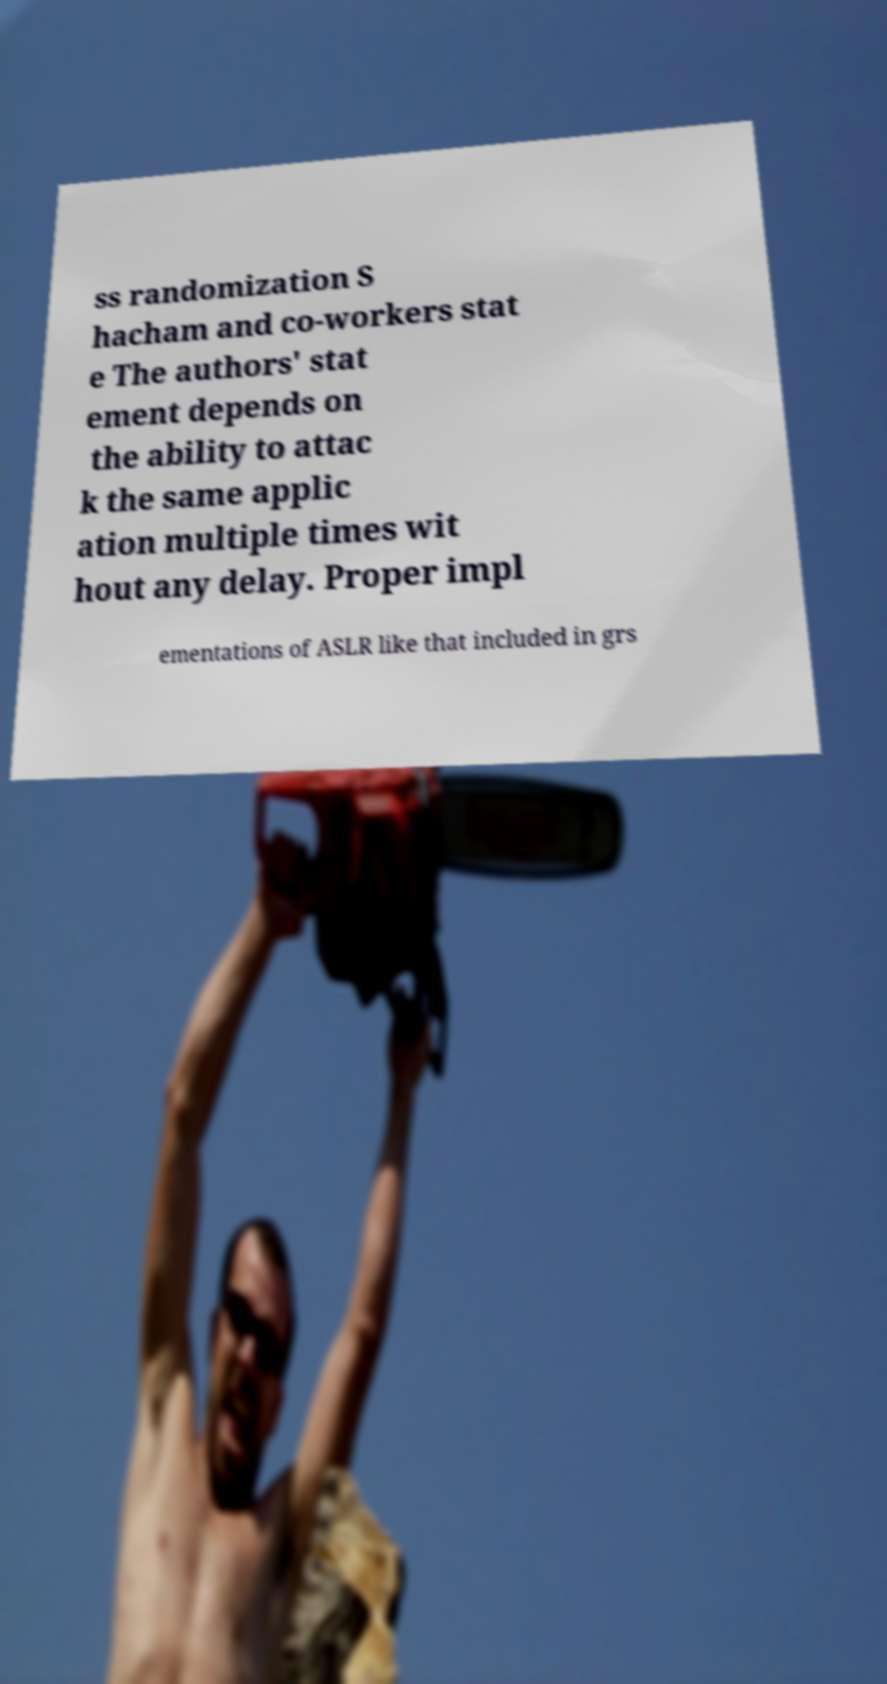What messages or text are displayed in this image? I need them in a readable, typed format. ss randomization S hacham and co-workers stat e The authors' stat ement depends on the ability to attac k the same applic ation multiple times wit hout any delay. Proper impl ementations of ASLR like that included in grs 